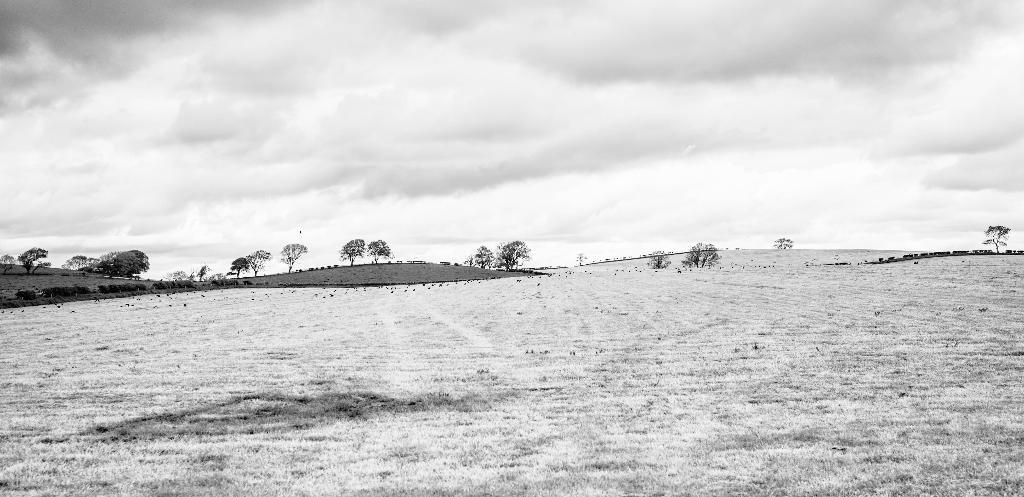What type of vegetation can be seen in the image? There are many trees in the image. What is covering the ground in the image? Grass is visible on the ground in the image. What can be seen in the sky in the image? There are clouds in the sky in the image. Is there a pipe visible in the image? No, there is no pipe present in the image. Can you see anyone saying good-bye in the image? No, there are no people or actions related to saying good-bye in the image. 